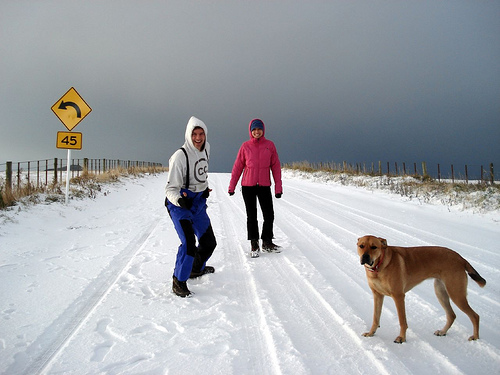<image>How high is the snow? I don't know how high the snow is. It can be anywhere from a few inches to 2 feet. How high is the snow? I don't know how high the snow is. It can be few inches, 1 inch, 2 inches, 5 inches, 3 inches, or even 2 feet. 